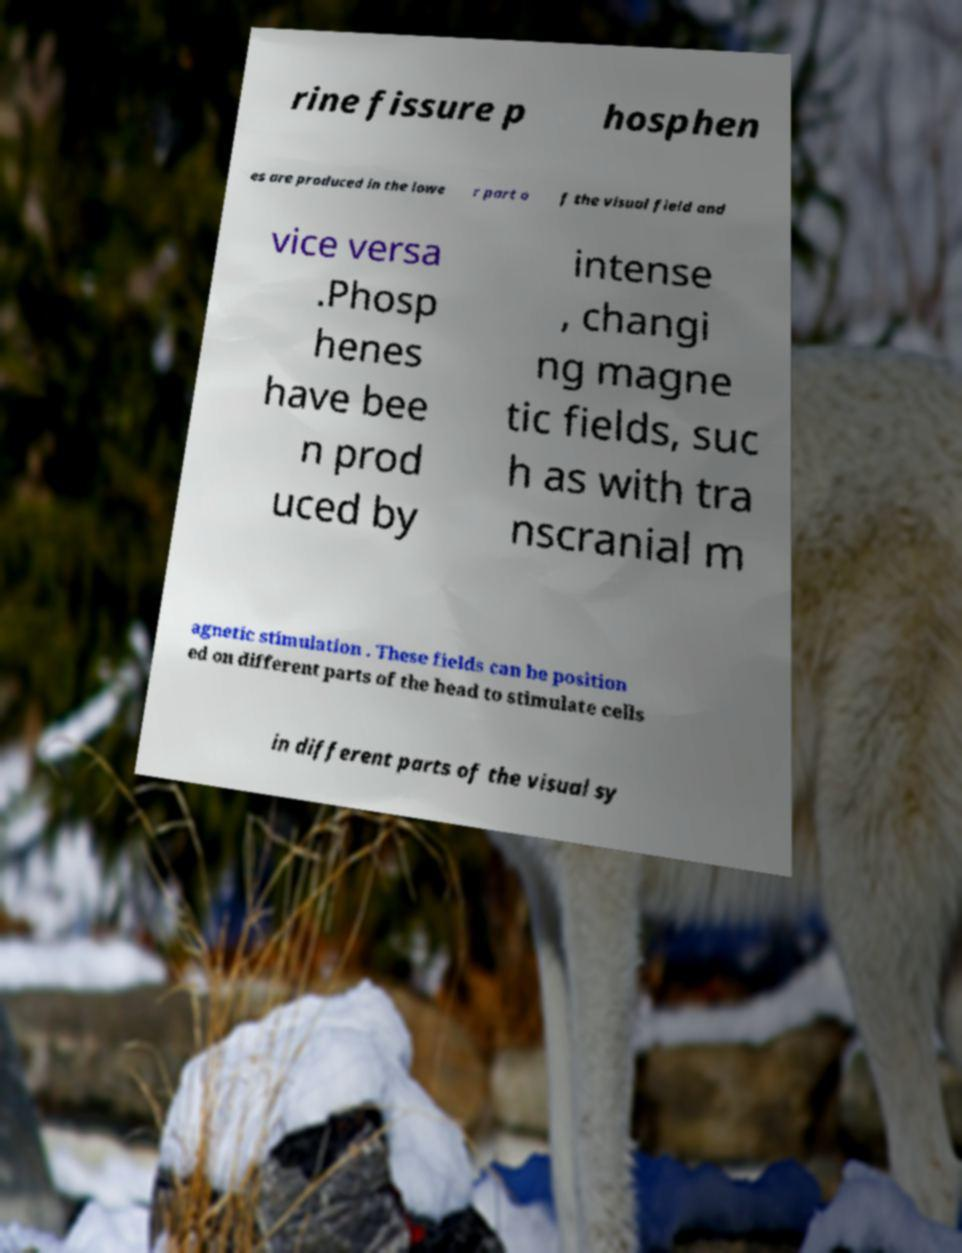I need the written content from this picture converted into text. Can you do that? rine fissure p hosphen es are produced in the lowe r part o f the visual field and vice versa .Phosp henes have bee n prod uced by intense , changi ng magne tic fields, suc h as with tra nscranial m agnetic stimulation . These fields can be position ed on different parts of the head to stimulate cells in different parts of the visual sy 